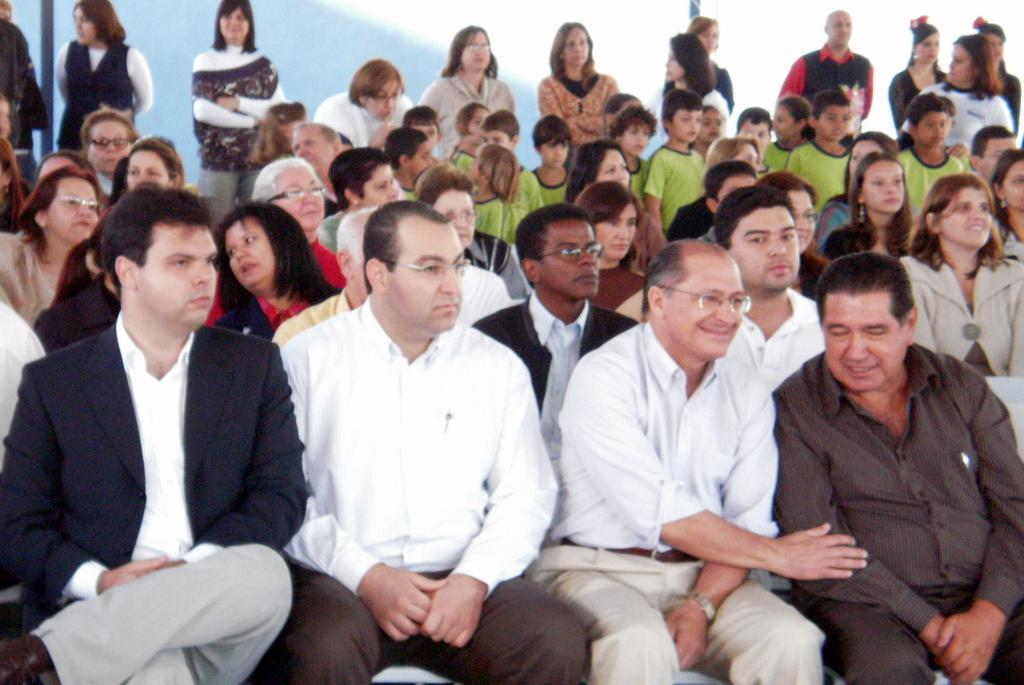What are the main subjects in the image? There is a group of persons sitting in the middle of the image, and some persons standing in the background. Can you describe the position of the persons in the image? The group of persons is sitting in the middle, while some others are standing in the background. What can be seen at the top of the image? There is a wall visible at the top of the image. What type of spade is being used by the persons in the image? There is no spade present in the image. How does the door in the image affect the visibility of the persons? There is no door present in the image. Can you describe the weather conditions in the image based on the presence of fog? There is no fog present in the image. 